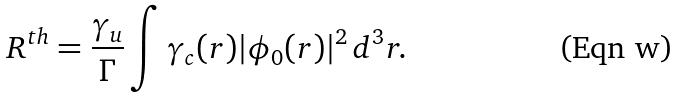<formula> <loc_0><loc_0><loc_500><loc_500>R ^ { t h } = \frac { \gamma _ { u } } { \Gamma } \int \gamma _ { c } ( { r } ) | \phi _ { 0 } ( { r } ) | ^ { 2 } \, d ^ { 3 } r .</formula> 